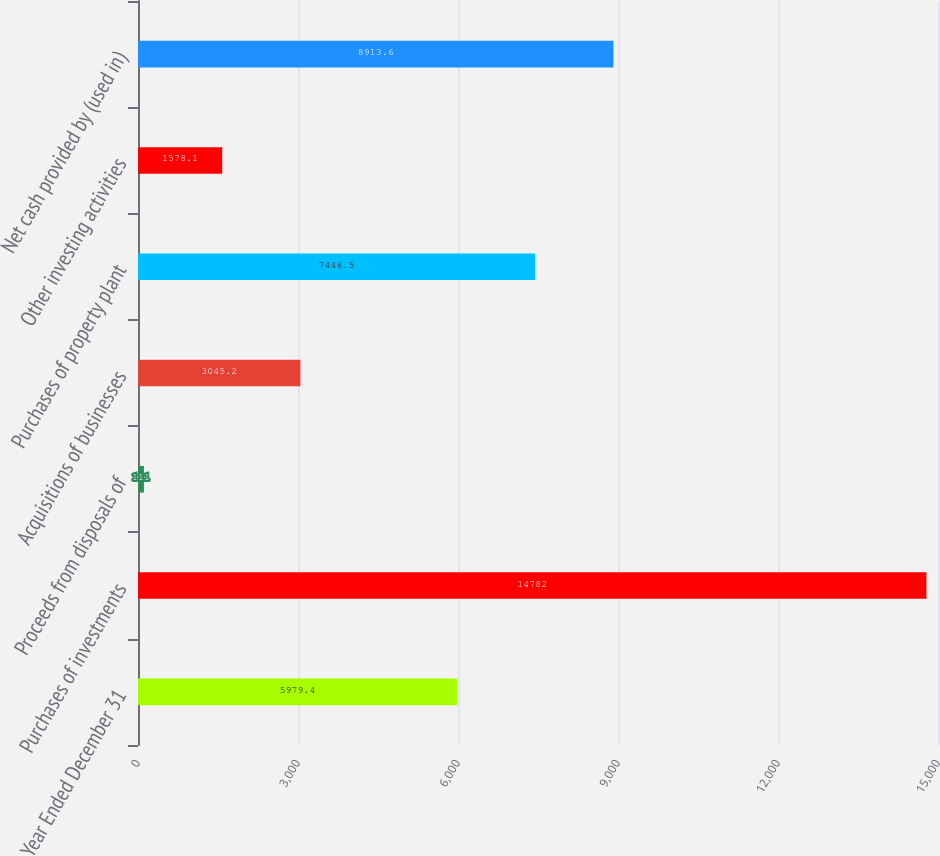Convert chart to OTSL. <chart><loc_0><loc_0><loc_500><loc_500><bar_chart><fcel>Year Ended December 31<fcel>Purchases of investments<fcel>Proceeds from disposals of<fcel>Acquisitions of businesses<fcel>Purchases of property plant<fcel>Other investing activities<fcel>Net cash provided by (used in)<nl><fcel>5979.4<fcel>14782<fcel>111<fcel>3045.2<fcel>7446.5<fcel>1578.1<fcel>8913.6<nl></chart> 